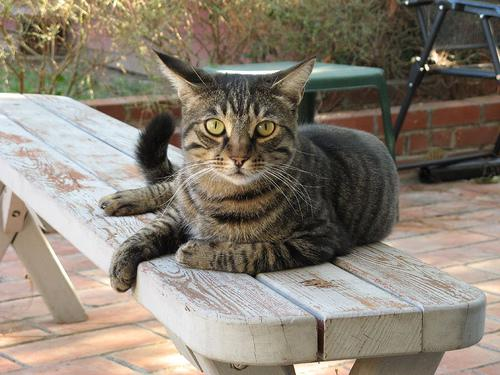Question: what is on the bench?
Choices:
A. A dog.
B. A cat.
C. A man.
D. A bird.
Answer with the letter. Answer: B Question: when was the picture taken?
Choices:
A. Nighttime.
B. Daytime.
C. Dawn.
D. Dusk.
Answer with the letter. Answer: B Question: why is the cat on the bench?
Choices:
A. Everywhere else is wet.
B. Laying.
C. Fear.
D. It's where the food is.
Answer with the letter. Answer: B 